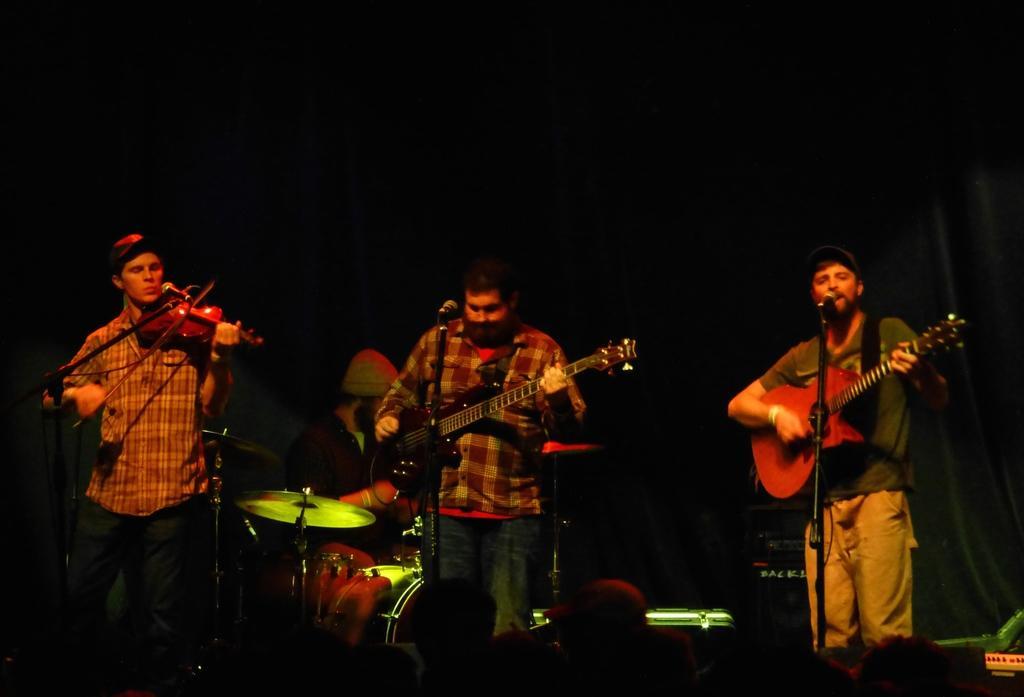Can you describe this image briefly? Here we can see four people standing on the stage and two people from the right are playing guitar and singing with microphone in front of them and the person on the left is playing violin and the person in the middle is playing drums 